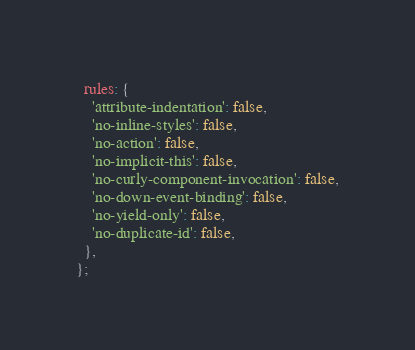<code> <loc_0><loc_0><loc_500><loc_500><_JavaScript_>  rules: {
    'attribute-indentation': false,
    'no-inline-styles': false,
    'no-action': false,
    'no-implicit-this': false,
    'no-curly-component-invocation': false,
    'no-down-event-binding': false,
    'no-yield-only': false,
    'no-duplicate-id': false,
  },
};
</code> 